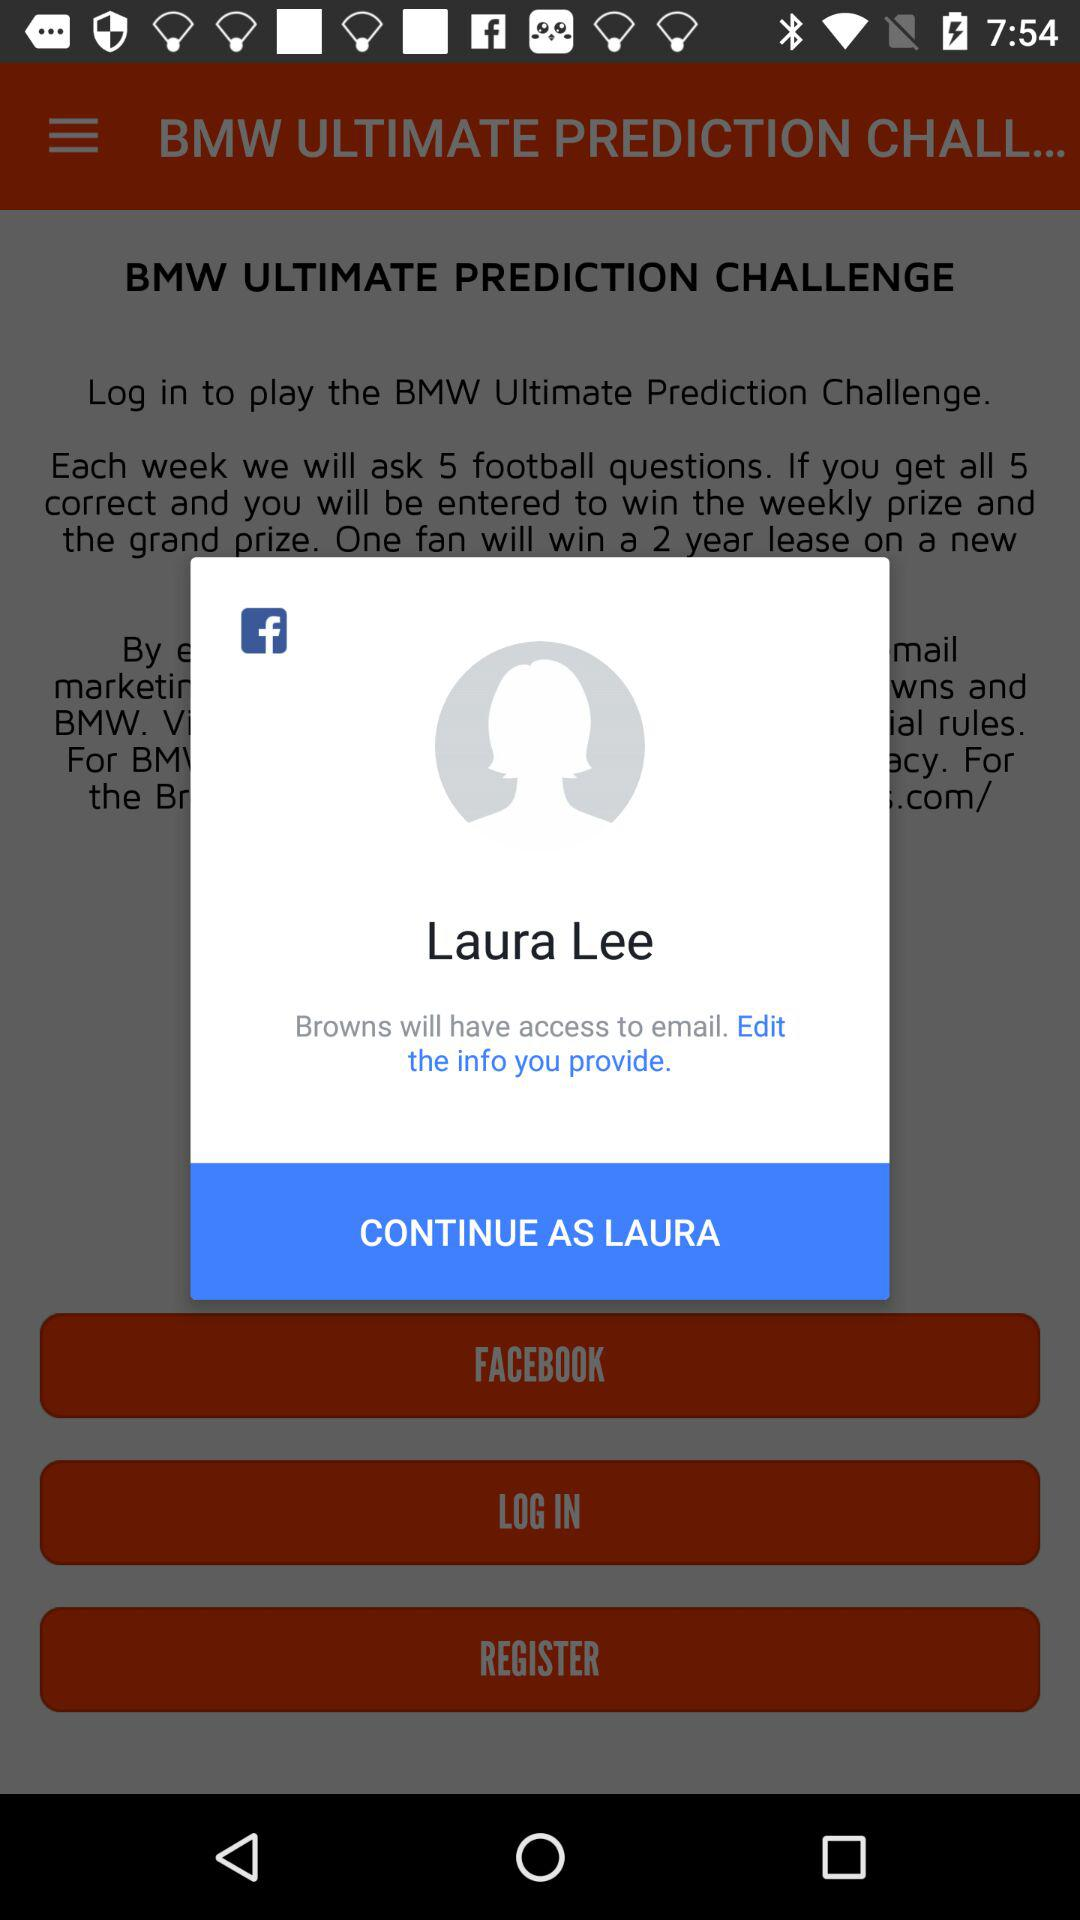What application will have access to email? The application "Browns" will have access to email. 